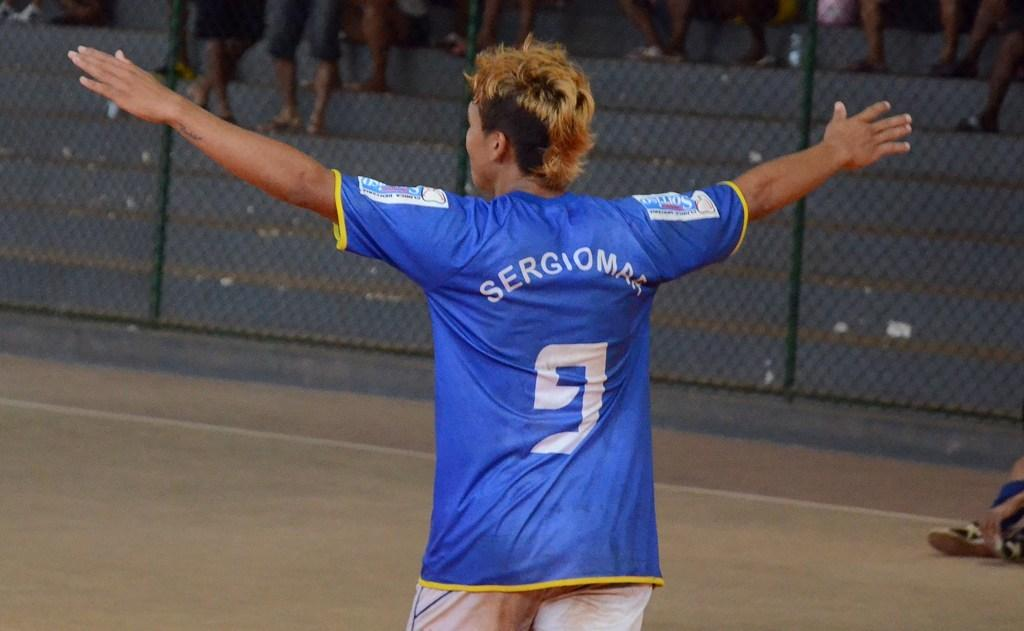<image>
Write a terse but informative summary of the picture. a sports player in a blue shirt with a white 9 on the back. 